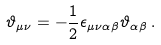Convert formula to latex. <formula><loc_0><loc_0><loc_500><loc_500>\vartheta _ { \mu \nu } = - \frac { 1 } { 2 } \epsilon _ { \mu \nu \alpha \beta } \vartheta _ { \alpha \beta } \, .</formula> 